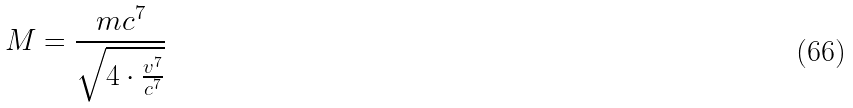<formula> <loc_0><loc_0><loc_500><loc_500>M = \frac { m c ^ { 7 } } { \sqrt { 4 \cdot \frac { v ^ { 7 } } { c ^ { 7 } } } }</formula> 